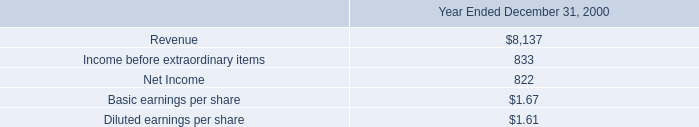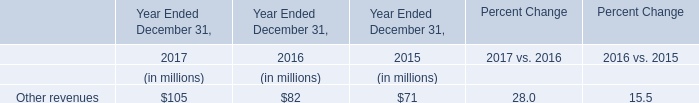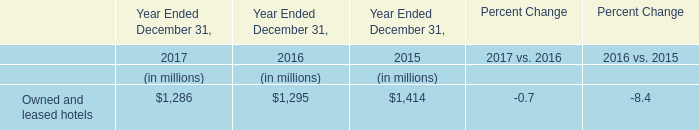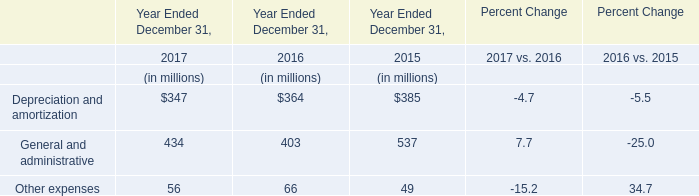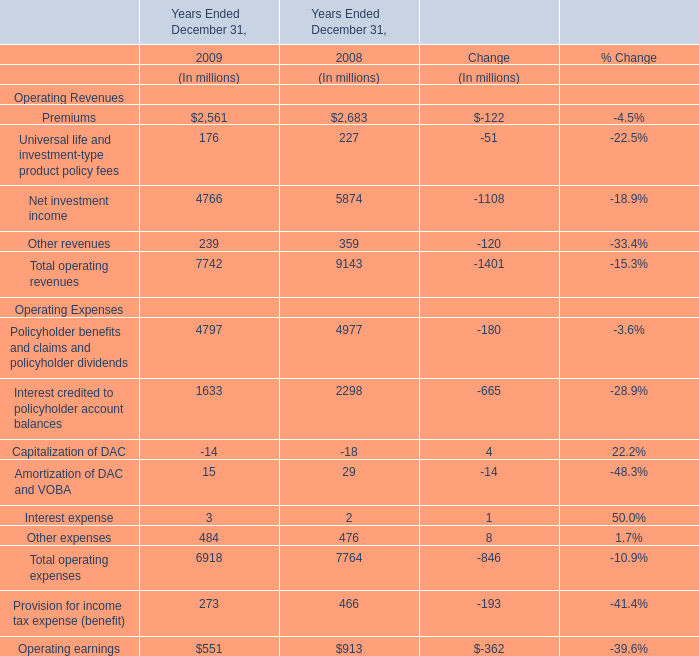If Other revenues develops with the same growth rate in 2009 ended December 31, what will it reach in 2010 ended December 31? (in million) 
Computations: (239 * (1 + ((239 - 359) / 359)))
Answer: 159.11142. 